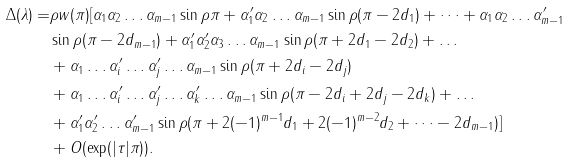<formula> <loc_0><loc_0><loc_500><loc_500>\Delta ( \lambda ) = & \rho w ( \pi ) [ \alpha _ { 1 } \alpha _ { 2 } \dots \alpha _ { m - 1 } \sin \rho \pi + \alpha ^ { \prime } _ { 1 } \alpha _ { 2 } \dots \alpha _ { m - 1 } \sin \rho ( \pi - 2 d _ { 1 } ) + \dots + \alpha _ { 1 } \alpha _ { 2 } \dots \alpha ^ { \prime } _ { m - 1 } \\ & \sin \rho ( \pi - 2 d _ { m - 1 } ) + \alpha ^ { \prime } _ { 1 } \alpha ^ { \prime } _ { 2 } \alpha _ { 3 } \dots \alpha _ { m - 1 } \sin \rho ( \pi + 2 d _ { 1 } - 2 d _ { 2 } ) + \dots \\ & + \alpha _ { 1 } \dots \alpha ^ { \prime } _ { i } \dots \alpha ^ { \prime } _ { j } \dots \alpha _ { m - 1 } \sin \rho ( \pi + 2 d _ { i } - 2 d _ { j } ) \\ & + \alpha _ { 1 } \dots \alpha ^ { \prime } _ { i } \dots \alpha ^ { \prime } _ { j } \dots \alpha ^ { \prime } _ { k } \dots \alpha _ { m - 1 } \sin \rho ( \pi - 2 d _ { i } + 2 d _ { j } - 2 d _ { k } ) + \dots \\ & + \alpha ^ { \prime } _ { 1 } \alpha ^ { \prime } _ { 2 } \dots \alpha ^ { \prime } _ { m - 1 } \sin \rho ( \pi + 2 ( - 1 ) ^ { m - 1 } d _ { 1 } + 2 ( - 1 ) ^ { m - 2 } d _ { 2 } + \dots - 2 d _ { m - 1 } ) ] \\ & + O ( \exp ( | \tau | \pi ) ) .</formula> 